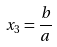Convert formula to latex. <formula><loc_0><loc_0><loc_500><loc_500>x _ { 3 } = \frac { b } { a }</formula> 